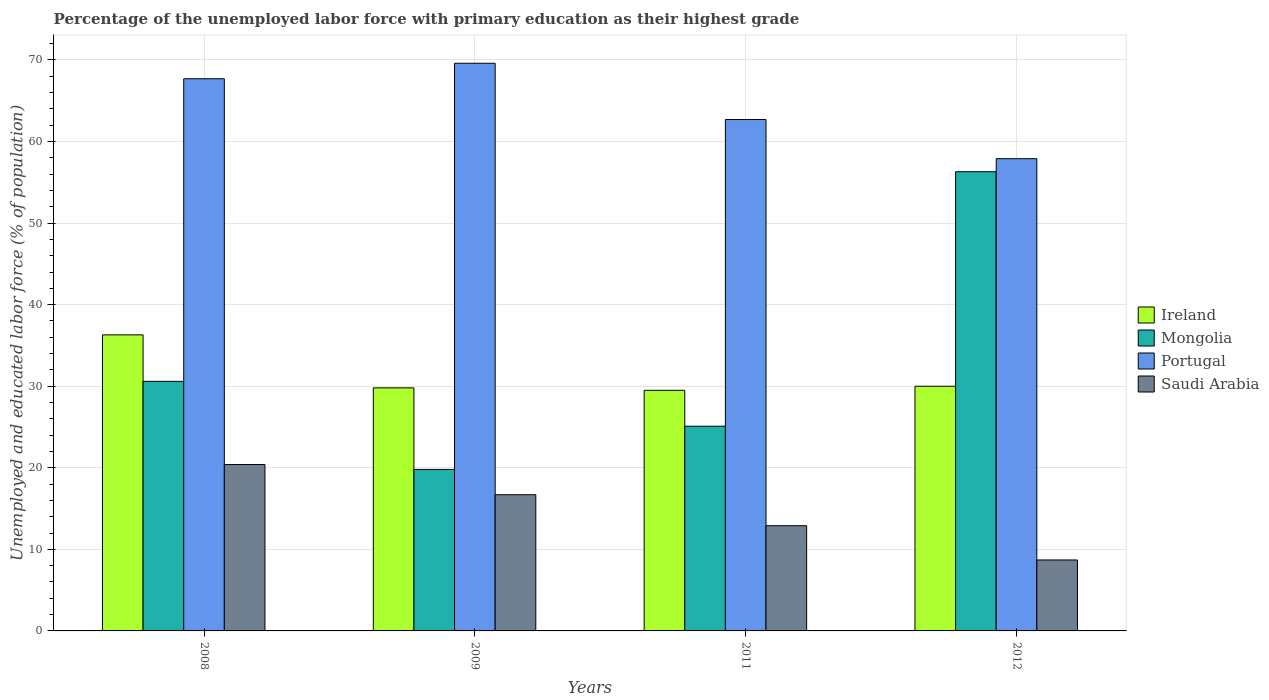How many bars are there on the 3rd tick from the left?
Ensure brevity in your answer.  4. How many bars are there on the 4th tick from the right?
Your answer should be very brief. 4. In how many cases, is the number of bars for a given year not equal to the number of legend labels?
Make the answer very short. 0. What is the percentage of the unemployed labor force with primary education in Saudi Arabia in 2009?
Ensure brevity in your answer.  16.7. Across all years, what is the maximum percentage of the unemployed labor force with primary education in Saudi Arabia?
Your response must be concise. 20.4. Across all years, what is the minimum percentage of the unemployed labor force with primary education in Mongolia?
Your answer should be very brief. 19.8. In which year was the percentage of the unemployed labor force with primary education in Ireland maximum?
Ensure brevity in your answer.  2008. In which year was the percentage of the unemployed labor force with primary education in Portugal minimum?
Offer a very short reply. 2012. What is the total percentage of the unemployed labor force with primary education in Saudi Arabia in the graph?
Offer a terse response. 58.7. What is the difference between the percentage of the unemployed labor force with primary education in Mongolia in 2008 and that in 2012?
Make the answer very short. -25.7. What is the difference between the percentage of the unemployed labor force with primary education in Ireland in 2011 and the percentage of the unemployed labor force with primary education in Portugal in 2012?
Ensure brevity in your answer.  -28.4. What is the average percentage of the unemployed labor force with primary education in Portugal per year?
Your answer should be compact. 64.47. In the year 2008, what is the difference between the percentage of the unemployed labor force with primary education in Ireland and percentage of the unemployed labor force with primary education in Portugal?
Give a very brief answer. -31.4. What is the ratio of the percentage of the unemployed labor force with primary education in Portugal in 2009 to that in 2011?
Ensure brevity in your answer.  1.11. Is the percentage of the unemployed labor force with primary education in Portugal in 2008 less than that in 2012?
Offer a very short reply. No. Is the difference between the percentage of the unemployed labor force with primary education in Ireland in 2009 and 2012 greater than the difference between the percentage of the unemployed labor force with primary education in Portugal in 2009 and 2012?
Your answer should be very brief. No. What is the difference between the highest and the second highest percentage of the unemployed labor force with primary education in Ireland?
Give a very brief answer. 6.3. What is the difference between the highest and the lowest percentage of the unemployed labor force with primary education in Ireland?
Your response must be concise. 6.8. Is the sum of the percentage of the unemployed labor force with primary education in Ireland in 2008 and 2009 greater than the maximum percentage of the unemployed labor force with primary education in Saudi Arabia across all years?
Offer a terse response. Yes. What does the 1st bar from the left in 2012 represents?
Make the answer very short. Ireland. What does the 2nd bar from the right in 2011 represents?
Offer a very short reply. Portugal. How many bars are there?
Make the answer very short. 16. Are all the bars in the graph horizontal?
Offer a terse response. No. Does the graph contain any zero values?
Your response must be concise. No. Where does the legend appear in the graph?
Your answer should be compact. Center right. What is the title of the graph?
Provide a succinct answer. Percentage of the unemployed labor force with primary education as their highest grade. Does "Kenya" appear as one of the legend labels in the graph?
Make the answer very short. No. What is the label or title of the Y-axis?
Your answer should be very brief. Unemployed and educated labor force (% of population). What is the Unemployed and educated labor force (% of population) in Ireland in 2008?
Ensure brevity in your answer.  36.3. What is the Unemployed and educated labor force (% of population) in Mongolia in 2008?
Keep it short and to the point. 30.6. What is the Unemployed and educated labor force (% of population) of Portugal in 2008?
Keep it short and to the point. 67.7. What is the Unemployed and educated labor force (% of population) of Saudi Arabia in 2008?
Your answer should be compact. 20.4. What is the Unemployed and educated labor force (% of population) of Ireland in 2009?
Give a very brief answer. 29.8. What is the Unemployed and educated labor force (% of population) in Mongolia in 2009?
Provide a succinct answer. 19.8. What is the Unemployed and educated labor force (% of population) of Portugal in 2009?
Make the answer very short. 69.6. What is the Unemployed and educated labor force (% of population) of Saudi Arabia in 2009?
Offer a terse response. 16.7. What is the Unemployed and educated labor force (% of population) in Ireland in 2011?
Your response must be concise. 29.5. What is the Unemployed and educated labor force (% of population) of Mongolia in 2011?
Keep it short and to the point. 25.1. What is the Unemployed and educated labor force (% of population) of Portugal in 2011?
Your response must be concise. 62.7. What is the Unemployed and educated labor force (% of population) in Saudi Arabia in 2011?
Ensure brevity in your answer.  12.9. What is the Unemployed and educated labor force (% of population) of Mongolia in 2012?
Your response must be concise. 56.3. What is the Unemployed and educated labor force (% of population) of Portugal in 2012?
Your response must be concise. 57.9. What is the Unemployed and educated labor force (% of population) of Saudi Arabia in 2012?
Offer a terse response. 8.7. Across all years, what is the maximum Unemployed and educated labor force (% of population) in Ireland?
Your response must be concise. 36.3. Across all years, what is the maximum Unemployed and educated labor force (% of population) in Mongolia?
Your answer should be very brief. 56.3. Across all years, what is the maximum Unemployed and educated labor force (% of population) in Portugal?
Your answer should be very brief. 69.6. Across all years, what is the maximum Unemployed and educated labor force (% of population) of Saudi Arabia?
Make the answer very short. 20.4. Across all years, what is the minimum Unemployed and educated labor force (% of population) of Ireland?
Your response must be concise. 29.5. Across all years, what is the minimum Unemployed and educated labor force (% of population) in Mongolia?
Make the answer very short. 19.8. Across all years, what is the minimum Unemployed and educated labor force (% of population) of Portugal?
Offer a terse response. 57.9. Across all years, what is the minimum Unemployed and educated labor force (% of population) of Saudi Arabia?
Your response must be concise. 8.7. What is the total Unemployed and educated labor force (% of population) of Ireland in the graph?
Give a very brief answer. 125.6. What is the total Unemployed and educated labor force (% of population) in Mongolia in the graph?
Your response must be concise. 131.8. What is the total Unemployed and educated labor force (% of population) in Portugal in the graph?
Provide a succinct answer. 257.9. What is the total Unemployed and educated labor force (% of population) in Saudi Arabia in the graph?
Provide a succinct answer. 58.7. What is the difference between the Unemployed and educated labor force (% of population) in Ireland in 2008 and that in 2009?
Your answer should be very brief. 6.5. What is the difference between the Unemployed and educated labor force (% of population) in Mongolia in 2008 and that in 2009?
Keep it short and to the point. 10.8. What is the difference between the Unemployed and educated labor force (% of population) in Portugal in 2008 and that in 2009?
Keep it short and to the point. -1.9. What is the difference between the Unemployed and educated labor force (% of population) of Saudi Arabia in 2008 and that in 2009?
Give a very brief answer. 3.7. What is the difference between the Unemployed and educated labor force (% of population) of Ireland in 2008 and that in 2011?
Your answer should be compact. 6.8. What is the difference between the Unemployed and educated labor force (% of population) in Portugal in 2008 and that in 2011?
Ensure brevity in your answer.  5. What is the difference between the Unemployed and educated labor force (% of population) of Saudi Arabia in 2008 and that in 2011?
Provide a short and direct response. 7.5. What is the difference between the Unemployed and educated labor force (% of population) of Mongolia in 2008 and that in 2012?
Offer a very short reply. -25.7. What is the difference between the Unemployed and educated labor force (% of population) of Ireland in 2009 and that in 2011?
Your answer should be compact. 0.3. What is the difference between the Unemployed and educated labor force (% of population) in Mongolia in 2009 and that in 2011?
Make the answer very short. -5.3. What is the difference between the Unemployed and educated labor force (% of population) of Portugal in 2009 and that in 2011?
Your response must be concise. 6.9. What is the difference between the Unemployed and educated labor force (% of population) of Saudi Arabia in 2009 and that in 2011?
Your answer should be very brief. 3.8. What is the difference between the Unemployed and educated labor force (% of population) in Ireland in 2009 and that in 2012?
Your answer should be compact. -0.2. What is the difference between the Unemployed and educated labor force (% of population) in Mongolia in 2009 and that in 2012?
Your answer should be very brief. -36.5. What is the difference between the Unemployed and educated labor force (% of population) of Portugal in 2009 and that in 2012?
Make the answer very short. 11.7. What is the difference between the Unemployed and educated labor force (% of population) of Saudi Arabia in 2009 and that in 2012?
Offer a very short reply. 8. What is the difference between the Unemployed and educated labor force (% of population) of Ireland in 2011 and that in 2012?
Give a very brief answer. -0.5. What is the difference between the Unemployed and educated labor force (% of population) in Mongolia in 2011 and that in 2012?
Provide a short and direct response. -31.2. What is the difference between the Unemployed and educated labor force (% of population) in Ireland in 2008 and the Unemployed and educated labor force (% of population) in Mongolia in 2009?
Your answer should be compact. 16.5. What is the difference between the Unemployed and educated labor force (% of population) of Ireland in 2008 and the Unemployed and educated labor force (% of population) of Portugal in 2009?
Your answer should be very brief. -33.3. What is the difference between the Unemployed and educated labor force (% of population) in Ireland in 2008 and the Unemployed and educated labor force (% of population) in Saudi Arabia in 2009?
Your answer should be very brief. 19.6. What is the difference between the Unemployed and educated labor force (% of population) in Mongolia in 2008 and the Unemployed and educated labor force (% of population) in Portugal in 2009?
Provide a short and direct response. -39. What is the difference between the Unemployed and educated labor force (% of population) in Mongolia in 2008 and the Unemployed and educated labor force (% of population) in Saudi Arabia in 2009?
Offer a very short reply. 13.9. What is the difference between the Unemployed and educated labor force (% of population) in Portugal in 2008 and the Unemployed and educated labor force (% of population) in Saudi Arabia in 2009?
Your answer should be very brief. 51. What is the difference between the Unemployed and educated labor force (% of population) in Ireland in 2008 and the Unemployed and educated labor force (% of population) in Mongolia in 2011?
Your answer should be very brief. 11.2. What is the difference between the Unemployed and educated labor force (% of population) in Ireland in 2008 and the Unemployed and educated labor force (% of population) in Portugal in 2011?
Your response must be concise. -26.4. What is the difference between the Unemployed and educated labor force (% of population) of Ireland in 2008 and the Unemployed and educated labor force (% of population) of Saudi Arabia in 2011?
Your response must be concise. 23.4. What is the difference between the Unemployed and educated labor force (% of population) in Mongolia in 2008 and the Unemployed and educated labor force (% of population) in Portugal in 2011?
Provide a short and direct response. -32.1. What is the difference between the Unemployed and educated labor force (% of population) of Portugal in 2008 and the Unemployed and educated labor force (% of population) of Saudi Arabia in 2011?
Your response must be concise. 54.8. What is the difference between the Unemployed and educated labor force (% of population) of Ireland in 2008 and the Unemployed and educated labor force (% of population) of Portugal in 2012?
Keep it short and to the point. -21.6. What is the difference between the Unemployed and educated labor force (% of population) of Ireland in 2008 and the Unemployed and educated labor force (% of population) of Saudi Arabia in 2012?
Ensure brevity in your answer.  27.6. What is the difference between the Unemployed and educated labor force (% of population) in Mongolia in 2008 and the Unemployed and educated labor force (% of population) in Portugal in 2012?
Offer a terse response. -27.3. What is the difference between the Unemployed and educated labor force (% of population) in Mongolia in 2008 and the Unemployed and educated labor force (% of population) in Saudi Arabia in 2012?
Provide a short and direct response. 21.9. What is the difference between the Unemployed and educated labor force (% of population) of Ireland in 2009 and the Unemployed and educated labor force (% of population) of Portugal in 2011?
Make the answer very short. -32.9. What is the difference between the Unemployed and educated labor force (% of population) in Ireland in 2009 and the Unemployed and educated labor force (% of population) in Saudi Arabia in 2011?
Offer a terse response. 16.9. What is the difference between the Unemployed and educated labor force (% of population) in Mongolia in 2009 and the Unemployed and educated labor force (% of population) in Portugal in 2011?
Keep it short and to the point. -42.9. What is the difference between the Unemployed and educated labor force (% of population) of Mongolia in 2009 and the Unemployed and educated labor force (% of population) of Saudi Arabia in 2011?
Offer a terse response. 6.9. What is the difference between the Unemployed and educated labor force (% of population) of Portugal in 2009 and the Unemployed and educated labor force (% of population) of Saudi Arabia in 2011?
Offer a very short reply. 56.7. What is the difference between the Unemployed and educated labor force (% of population) of Ireland in 2009 and the Unemployed and educated labor force (% of population) of Mongolia in 2012?
Make the answer very short. -26.5. What is the difference between the Unemployed and educated labor force (% of population) of Ireland in 2009 and the Unemployed and educated labor force (% of population) of Portugal in 2012?
Offer a terse response. -28.1. What is the difference between the Unemployed and educated labor force (% of population) of Ireland in 2009 and the Unemployed and educated labor force (% of population) of Saudi Arabia in 2012?
Keep it short and to the point. 21.1. What is the difference between the Unemployed and educated labor force (% of population) of Mongolia in 2009 and the Unemployed and educated labor force (% of population) of Portugal in 2012?
Make the answer very short. -38.1. What is the difference between the Unemployed and educated labor force (% of population) of Mongolia in 2009 and the Unemployed and educated labor force (% of population) of Saudi Arabia in 2012?
Provide a succinct answer. 11.1. What is the difference between the Unemployed and educated labor force (% of population) in Portugal in 2009 and the Unemployed and educated labor force (% of population) in Saudi Arabia in 2012?
Your answer should be compact. 60.9. What is the difference between the Unemployed and educated labor force (% of population) of Ireland in 2011 and the Unemployed and educated labor force (% of population) of Mongolia in 2012?
Your answer should be very brief. -26.8. What is the difference between the Unemployed and educated labor force (% of population) in Ireland in 2011 and the Unemployed and educated labor force (% of population) in Portugal in 2012?
Provide a short and direct response. -28.4. What is the difference between the Unemployed and educated labor force (% of population) in Ireland in 2011 and the Unemployed and educated labor force (% of population) in Saudi Arabia in 2012?
Make the answer very short. 20.8. What is the difference between the Unemployed and educated labor force (% of population) in Mongolia in 2011 and the Unemployed and educated labor force (% of population) in Portugal in 2012?
Ensure brevity in your answer.  -32.8. What is the difference between the Unemployed and educated labor force (% of population) of Mongolia in 2011 and the Unemployed and educated labor force (% of population) of Saudi Arabia in 2012?
Make the answer very short. 16.4. What is the average Unemployed and educated labor force (% of population) of Ireland per year?
Provide a succinct answer. 31.4. What is the average Unemployed and educated labor force (% of population) of Mongolia per year?
Give a very brief answer. 32.95. What is the average Unemployed and educated labor force (% of population) in Portugal per year?
Provide a succinct answer. 64.47. What is the average Unemployed and educated labor force (% of population) of Saudi Arabia per year?
Make the answer very short. 14.68. In the year 2008, what is the difference between the Unemployed and educated labor force (% of population) of Ireland and Unemployed and educated labor force (% of population) of Portugal?
Make the answer very short. -31.4. In the year 2008, what is the difference between the Unemployed and educated labor force (% of population) in Ireland and Unemployed and educated labor force (% of population) in Saudi Arabia?
Provide a succinct answer. 15.9. In the year 2008, what is the difference between the Unemployed and educated labor force (% of population) of Mongolia and Unemployed and educated labor force (% of population) of Portugal?
Offer a terse response. -37.1. In the year 2008, what is the difference between the Unemployed and educated labor force (% of population) in Mongolia and Unemployed and educated labor force (% of population) in Saudi Arabia?
Offer a very short reply. 10.2. In the year 2008, what is the difference between the Unemployed and educated labor force (% of population) in Portugal and Unemployed and educated labor force (% of population) in Saudi Arabia?
Offer a very short reply. 47.3. In the year 2009, what is the difference between the Unemployed and educated labor force (% of population) in Ireland and Unemployed and educated labor force (% of population) in Mongolia?
Make the answer very short. 10. In the year 2009, what is the difference between the Unemployed and educated labor force (% of population) of Ireland and Unemployed and educated labor force (% of population) of Portugal?
Provide a short and direct response. -39.8. In the year 2009, what is the difference between the Unemployed and educated labor force (% of population) of Ireland and Unemployed and educated labor force (% of population) of Saudi Arabia?
Your answer should be very brief. 13.1. In the year 2009, what is the difference between the Unemployed and educated labor force (% of population) of Mongolia and Unemployed and educated labor force (% of population) of Portugal?
Provide a succinct answer. -49.8. In the year 2009, what is the difference between the Unemployed and educated labor force (% of population) in Portugal and Unemployed and educated labor force (% of population) in Saudi Arabia?
Your answer should be very brief. 52.9. In the year 2011, what is the difference between the Unemployed and educated labor force (% of population) of Ireland and Unemployed and educated labor force (% of population) of Portugal?
Make the answer very short. -33.2. In the year 2011, what is the difference between the Unemployed and educated labor force (% of population) in Mongolia and Unemployed and educated labor force (% of population) in Portugal?
Make the answer very short. -37.6. In the year 2011, what is the difference between the Unemployed and educated labor force (% of population) in Portugal and Unemployed and educated labor force (% of population) in Saudi Arabia?
Keep it short and to the point. 49.8. In the year 2012, what is the difference between the Unemployed and educated labor force (% of population) in Ireland and Unemployed and educated labor force (% of population) in Mongolia?
Provide a succinct answer. -26.3. In the year 2012, what is the difference between the Unemployed and educated labor force (% of population) in Ireland and Unemployed and educated labor force (% of population) in Portugal?
Your answer should be compact. -27.9. In the year 2012, what is the difference between the Unemployed and educated labor force (% of population) in Ireland and Unemployed and educated labor force (% of population) in Saudi Arabia?
Give a very brief answer. 21.3. In the year 2012, what is the difference between the Unemployed and educated labor force (% of population) of Mongolia and Unemployed and educated labor force (% of population) of Saudi Arabia?
Your response must be concise. 47.6. In the year 2012, what is the difference between the Unemployed and educated labor force (% of population) of Portugal and Unemployed and educated labor force (% of population) of Saudi Arabia?
Make the answer very short. 49.2. What is the ratio of the Unemployed and educated labor force (% of population) in Ireland in 2008 to that in 2009?
Ensure brevity in your answer.  1.22. What is the ratio of the Unemployed and educated labor force (% of population) of Mongolia in 2008 to that in 2009?
Your response must be concise. 1.55. What is the ratio of the Unemployed and educated labor force (% of population) of Portugal in 2008 to that in 2009?
Keep it short and to the point. 0.97. What is the ratio of the Unemployed and educated labor force (% of population) of Saudi Arabia in 2008 to that in 2009?
Your answer should be very brief. 1.22. What is the ratio of the Unemployed and educated labor force (% of population) of Ireland in 2008 to that in 2011?
Give a very brief answer. 1.23. What is the ratio of the Unemployed and educated labor force (% of population) of Mongolia in 2008 to that in 2011?
Your answer should be very brief. 1.22. What is the ratio of the Unemployed and educated labor force (% of population) in Portugal in 2008 to that in 2011?
Ensure brevity in your answer.  1.08. What is the ratio of the Unemployed and educated labor force (% of population) of Saudi Arabia in 2008 to that in 2011?
Your answer should be very brief. 1.58. What is the ratio of the Unemployed and educated labor force (% of population) in Ireland in 2008 to that in 2012?
Make the answer very short. 1.21. What is the ratio of the Unemployed and educated labor force (% of population) of Mongolia in 2008 to that in 2012?
Your answer should be compact. 0.54. What is the ratio of the Unemployed and educated labor force (% of population) in Portugal in 2008 to that in 2012?
Provide a short and direct response. 1.17. What is the ratio of the Unemployed and educated labor force (% of population) of Saudi Arabia in 2008 to that in 2012?
Keep it short and to the point. 2.34. What is the ratio of the Unemployed and educated labor force (% of population) in Ireland in 2009 to that in 2011?
Give a very brief answer. 1.01. What is the ratio of the Unemployed and educated labor force (% of population) in Mongolia in 2009 to that in 2011?
Your response must be concise. 0.79. What is the ratio of the Unemployed and educated labor force (% of population) of Portugal in 2009 to that in 2011?
Keep it short and to the point. 1.11. What is the ratio of the Unemployed and educated labor force (% of population) in Saudi Arabia in 2009 to that in 2011?
Offer a terse response. 1.29. What is the ratio of the Unemployed and educated labor force (% of population) of Mongolia in 2009 to that in 2012?
Offer a terse response. 0.35. What is the ratio of the Unemployed and educated labor force (% of population) in Portugal in 2009 to that in 2012?
Give a very brief answer. 1.2. What is the ratio of the Unemployed and educated labor force (% of population) of Saudi Arabia in 2009 to that in 2012?
Offer a terse response. 1.92. What is the ratio of the Unemployed and educated labor force (% of population) of Ireland in 2011 to that in 2012?
Ensure brevity in your answer.  0.98. What is the ratio of the Unemployed and educated labor force (% of population) of Mongolia in 2011 to that in 2012?
Give a very brief answer. 0.45. What is the ratio of the Unemployed and educated labor force (% of population) of Portugal in 2011 to that in 2012?
Offer a terse response. 1.08. What is the ratio of the Unemployed and educated labor force (% of population) in Saudi Arabia in 2011 to that in 2012?
Your answer should be compact. 1.48. What is the difference between the highest and the second highest Unemployed and educated labor force (% of population) in Mongolia?
Provide a succinct answer. 25.7. What is the difference between the highest and the second highest Unemployed and educated labor force (% of population) of Portugal?
Your answer should be compact. 1.9. What is the difference between the highest and the lowest Unemployed and educated labor force (% of population) in Ireland?
Give a very brief answer. 6.8. What is the difference between the highest and the lowest Unemployed and educated labor force (% of population) in Mongolia?
Your answer should be compact. 36.5. 